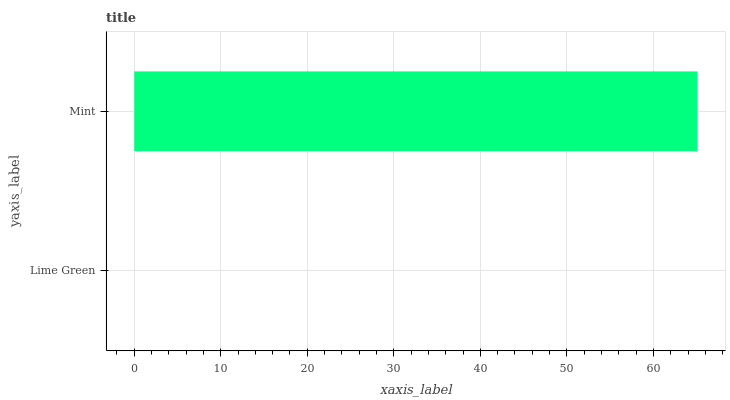Is Lime Green the minimum?
Answer yes or no. Yes. Is Mint the maximum?
Answer yes or no. Yes. Is Mint the minimum?
Answer yes or no. No. Is Mint greater than Lime Green?
Answer yes or no. Yes. Is Lime Green less than Mint?
Answer yes or no. Yes. Is Lime Green greater than Mint?
Answer yes or no. No. Is Mint less than Lime Green?
Answer yes or no. No. Is Mint the high median?
Answer yes or no. Yes. Is Lime Green the low median?
Answer yes or no. Yes. Is Lime Green the high median?
Answer yes or no. No. Is Mint the low median?
Answer yes or no. No. 